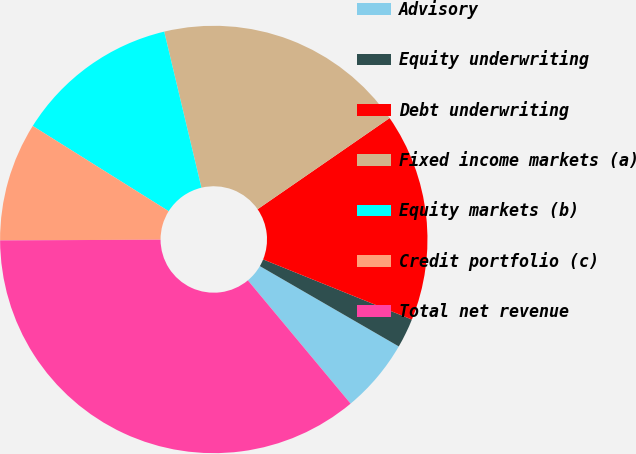Convert chart. <chart><loc_0><loc_0><loc_500><loc_500><pie_chart><fcel>Advisory<fcel>Equity underwriting<fcel>Debt underwriting<fcel>Fixed income markets (a)<fcel>Equity markets (b)<fcel>Credit portfolio (c)<fcel>Total net revenue<nl><fcel>5.6%<fcel>2.23%<fcel>15.73%<fcel>19.11%<fcel>12.36%<fcel>8.98%<fcel>35.99%<nl></chart> 